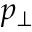Convert formula to latex. <formula><loc_0><loc_0><loc_500><loc_500>p _ { \perp }</formula> 